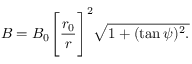Convert formula to latex. <formula><loc_0><loc_0><loc_500><loc_500>B = B _ { 0 } \left [ \frac { r _ { 0 } } { r } \right ] ^ { 2 } \sqrt { 1 + ( \tan \psi ) ^ { 2 } . }</formula> 